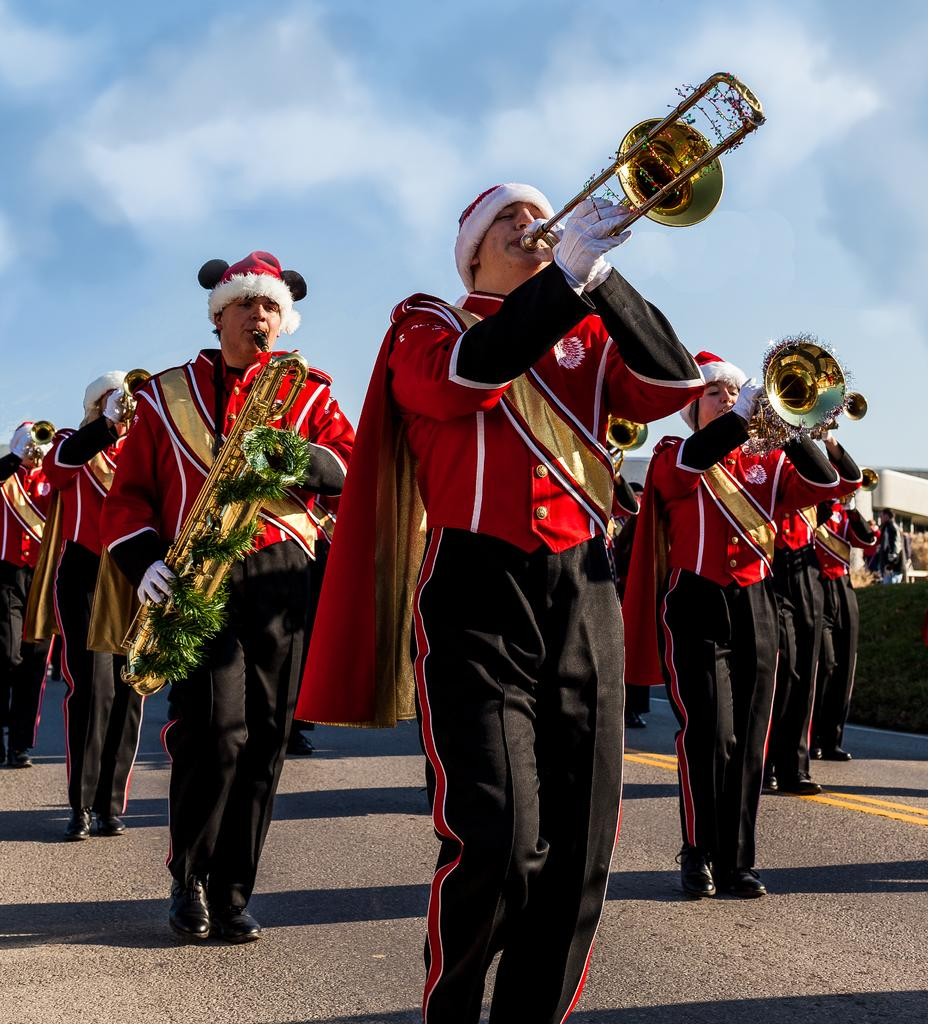Who or what can be seen in the image? There are people in the image. What are some of the people doing in the image? Some people are playing a musical instrument on the road. What can be seen in the distance in the image? There is a sky visible in the background of the image. What type of cake is being served at the start of the year in the image? There is no cake or reference to a specific time of year in the image. 